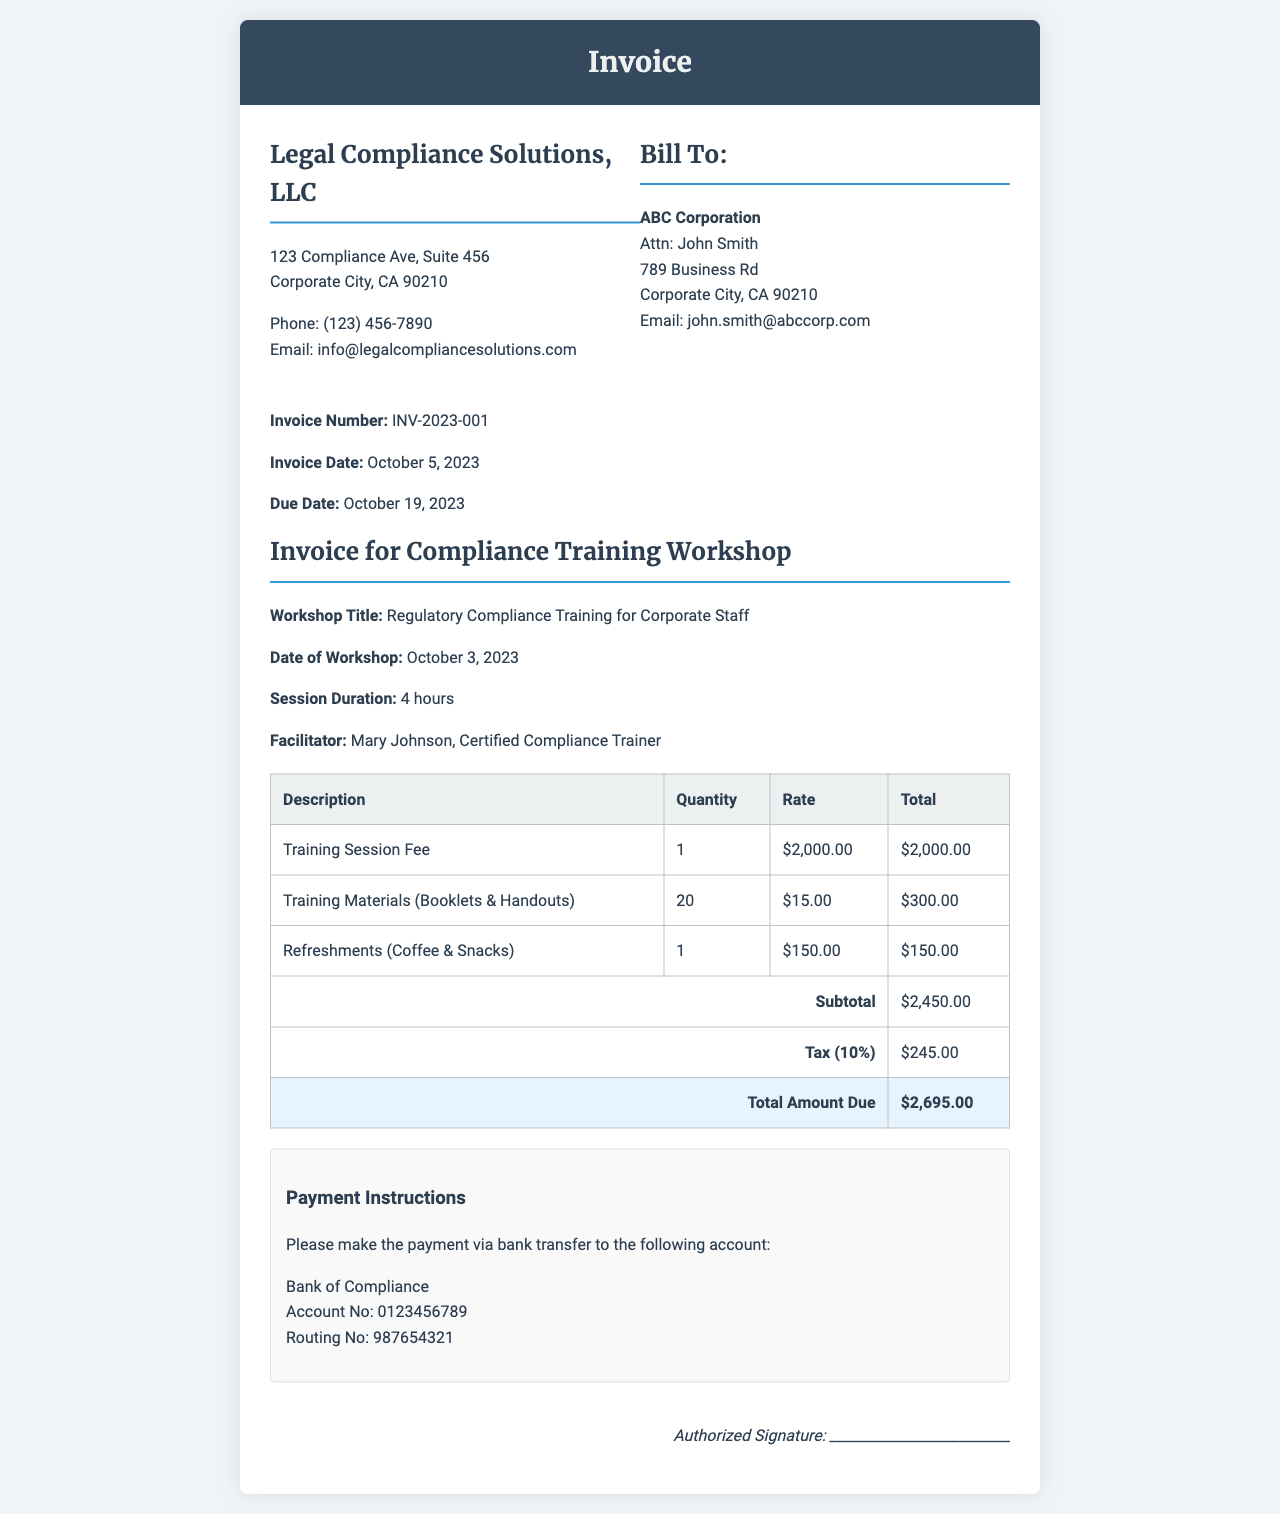What is the name of the company issuing the invoice? The company issuing the invoice is identified in the header as Legal Compliance Solutions, LLC.
Answer: Legal Compliance Solutions, LLC What is the invoice number? The specific invoice number is listed in the document under invoice info as INV-2023-001.
Answer: INV-2023-001 What date was the workshop held? The document specifies the date of the workshop in the title section as October 3, 2023.
Answer: October 3, 2023 What is the subtotal amount before tax? The subtotal is calculated from the itemized charges, which is presented in the table as $2,450.00.
Answer: $2,450.00 What is the total amount due? The total amount due at the end of the invoice is stated as $2,695.00.
Answer: $2,695.00 Who was the facilitator for the training session? The facilitator's name is mentioned in the document as Mary Johnson, Certified Compliance Trainer.
Answer: Mary Johnson, Certified Compliance Trainer How many training materials were provided? The number of training materials is listed in the table with a quantity of 20.
Answer: 20 What is the tax rate applied to the subtotal? The tax rate is mentioned in the document as 10% of the subtotal.
Answer: 10% What method of payment is specified in the invoice? The payment instructions indicate that the payment method is via bank transfer.
Answer: Bank transfer 